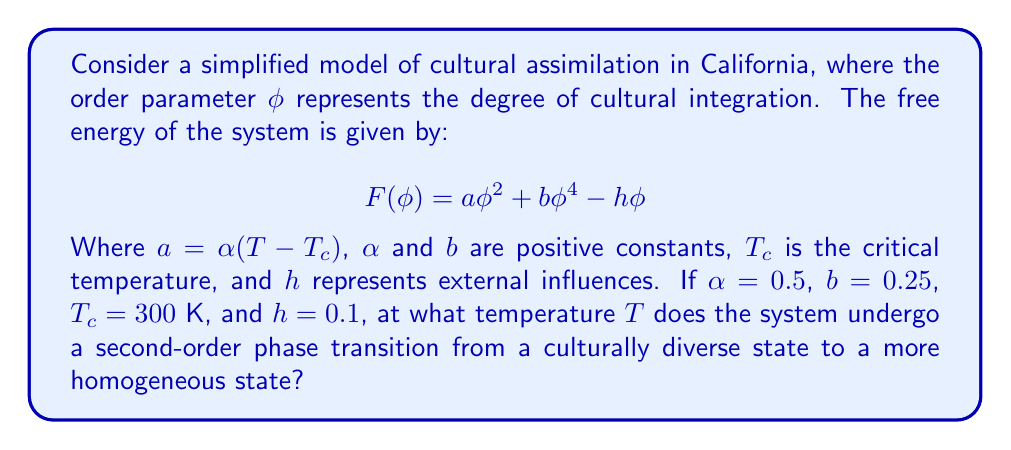Show me your answer to this math problem. To solve this problem, we'll follow these steps:

1) A second-order phase transition occurs when the system smoothly transitions from one phase to another. This happens when the coefficient of $\phi^2$ in the free energy equation changes sign.

2) In our equation, this coefficient is $a$, which is defined as $a = \alpha(T - T_c)$.

3) The transition occurs when $a = 0$, i.e., when $T = T_c$.

4) We are given that $T_c = 300$ K.

5) Therefore, the second-order phase transition occurs at $T = T_c = 300$ K.

6) At temperatures above 300 K, $a > 0$, and the system tends towards a culturally diverse state (small $\phi$).

7) At temperatures below 300 K, $a < 0$, and the system tends towards a more homogeneous state (larger $\phi$).

Note: The values of $\alpha$, $b$, and $h$ don't affect the temperature at which the phase transition occurs in this case, but they would influence the behavior of the order parameter $\phi$ around the transition.
Answer: 300 K 